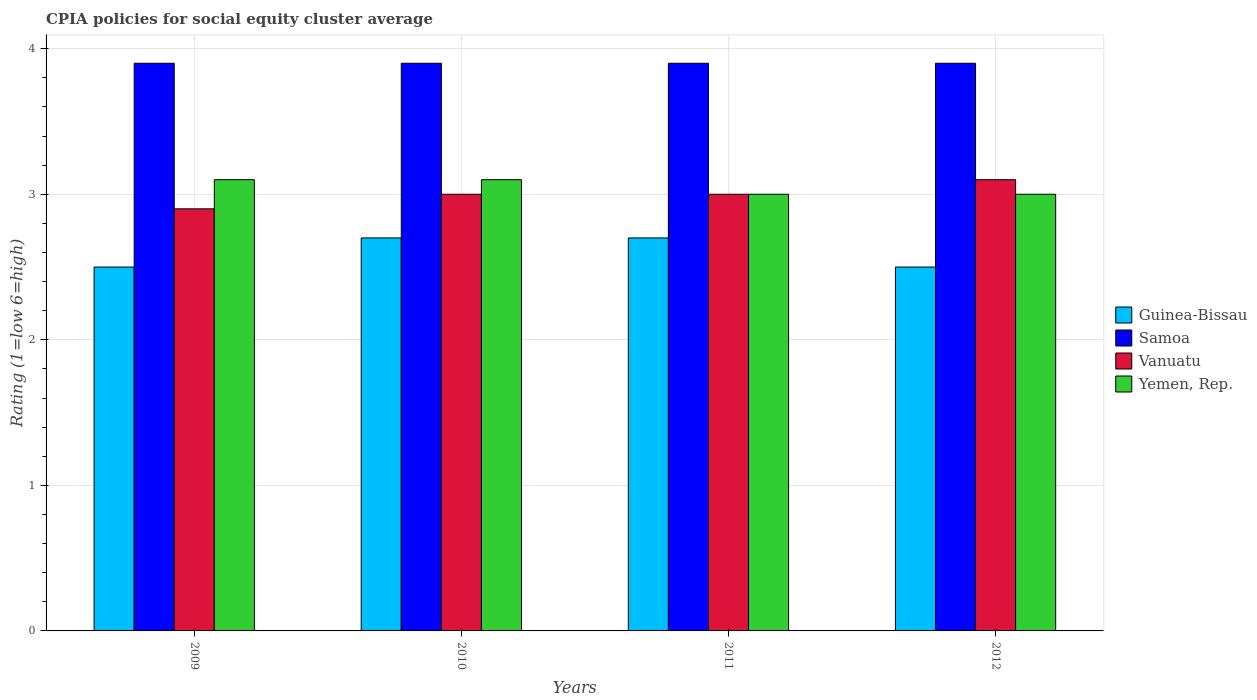How many different coloured bars are there?
Give a very brief answer. 4. Are the number of bars per tick equal to the number of legend labels?
Your answer should be very brief. Yes. What is the difference between the CPIA rating in Guinea-Bissau in 2010 and the CPIA rating in Vanuatu in 2012?
Offer a terse response. -0.4. What is the average CPIA rating in Yemen, Rep. per year?
Offer a very short reply. 3.05. In the year 2009, what is the difference between the CPIA rating in Guinea-Bissau and CPIA rating in Yemen, Rep.?
Your response must be concise. -0.6. In how many years, is the CPIA rating in Samoa greater than 0.8?
Ensure brevity in your answer.  4. Is the CPIA rating in Yemen, Rep. in 2009 less than that in 2012?
Ensure brevity in your answer.  No. What is the difference between the highest and the second highest CPIA rating in Vanuatu?
Provide a short and direct response. 0.1. What is the difference between the highest and the lowest CPIA rating in Yemen, Rep.?
Your answer should be very brief. 0.1. Is the sum of the CPIA rating in Vanuatu in 2009 and 2010 greater than the maximum CPIA rating in Samoa across all years?
Your response must be concise. Yes. Is it the case that in every year, the sum of the CPIA rating in Yemen, Rep. and CPIA rating in Vanuatu is greater than the sum of CPIA rating in Guinea-Bissau and CPIA rating in Samoa?
Offer a very short reply. No. What does the 3rd bar from the left in 2012 represents?
Offer a very short reply. Vanuatu. What does the 4th bar from the right in 2012 represents?
Ensure brevity in your answer.  Guinea-Bissau. How many years are there in the graph?
Offer a very short reply. 4. Does the graph contain grids?
Provide a succinct answer. Yes. How many legend labels are there?
Make the answer very short. 4. How are the legend labels stacked?
Provide a succinct answer. Vertical. What is the title of the graph?
Provide a short and direct response. CPIA policies for social equity cluster average. Does "Sri Lanka" appear as one of the legend labels in the graph?
Offer a terse response. No. What is the Rating (1=low 6=high) of Guinea-Bissau in 2009?
Make the answer very short. 2.5. What is the Rating (1=low 6=high) in Samoa in 2009?
Make the answer very short. 3.9. What is the Rating (1=low 6=high) of Guinea-Bissau in 2010?
Give a very brief answer. 2.7. What is the Rating (1=low 6=high) in Vanuatu in 2010?
Ensure brevity in your answer.  3. What is the Rating (1=low 6=high) in Guinea-Bissau in 2011?
Keep it short and to the point. 2.7. What is the Rating (1=low 6=high) of Samoa in 2011?
Give a very brief answer. 3.9. What is the Rating (1=low 6=high) of Vanuatu in 2011?
Offer a terse response. 3. What is the Rating (1=low 6=high) of Guinea-Bissau in 2012?
Your answer should be compact. 2.5. What is the Rating (1=low 6=high) of Vanuatu in 2012?
Offer a very short reply. 3.1. What is the Rating (1=low 6=high) of Yemen, Rep. in 2012?
Offer a very short reply. 3. Across all years, what is the maximum Rating (1=low 6=high) in Guinea-Bissau?
Provide a short and direct response. 2.7. Across all years, what is the maximum Rating (1=low 6=high) of Samoa?
Ensure brevity in your answer.  3.9. Across all years, what is the maximum Rating (1=low 6=high) of Vanuatu?
Keep it short and to the point. 3.1. Across all years, what is the minimum Rating (1=low 6=high) in Guinea-Bissau?
Ensure brevity in your answer.  2.5. Across all years, what is the minimum Rating (1=low 6=high) of Vanuatu?
Keep it short and to the point. 2.9. What is the total Rating (1=low 6=high) in Samoa in the graph?
Offer a very short reply. 15.6. What is the difference between the Rating (1=low 6=high) of Guinea-Bissau in 2009 and that in 2010?
Ensure brevity in your answer.  -0.2. What is the difference between the Rating (1=low 6=high) in Guinea-Bissau in 2009 and that in 2011?
Give a very brief answer. -0.2. What is the difference between the Rating (1=low 6=high) in Vanuatu in 2009 and that in 2011?
Give a very brief answer. -0.1. What is the difference between the Rating (1=low 6=high) in Guinea-Bissau in 2009 and that in 2012?
Offer a very short reply. 0. What is the difference between the Rating (1=low 6=high) in Samoa in 2009 and that in 2012?
Your response must be concise. 0. What is the difference between the Rating (1=low 6=high) in Vanuatu in 2009 and that in 2012?
Keep it short and to the point. -0.2. What is the difference between the Rating (1=low 6=high) of Yemen, Rep. in 2009 and that in 2012?
Your response must be concise. 0.1. What is the difference between the Rating (1=low 6=high) in Guinea-Bissau in 2010 and that in 2011?
Your response must be concise. 0. What is the difference between the Rating (1=low 6=high) in Vanuatu in 2010 and that in 2011?
Provide a succinct answer. 0. What is the difference between the Rating (1=low 6=high) of Samoa in 2010 and that in 2012?
Your response must be concise. 0. What is the difference between the Rating (1=low 6=high) of Guinea-Bissau in 2009 and the Rating (1=low 6=high) of Vanuatu in 2010?
Your answer should be very brief. -0.5. What is the difference between the Rating (1=low 6=high) in Samoa in 2009 and the Rating (1=low 6=high) in Vanuatu in 2010?
Give a very brief answer. 0.9. What is the difference between the Rating (1=low 6=high) in Guinea-Bissau in 2009 and the Rating (1=low 6=high) in Samoa in 2011?
Your response must be concise. -1.4. What is the difference between the Rating (1=low 6=high) in Guinea-Bissau in 2009 and the Rating (1=low 6=high) in Vanuatu in 2011?
Offer a terse response. -0.5. What is the difference between the Rating (1=low 6=high) in Samoa in 2009 and the Rating (1=low 6=high) in Yemen, Rep. in 2011?
Give a very brief answer. 0.9. What is the difference between the Rating (1=low 6=high) in Vanuatu in 2009 and the Rating (1=low 6=high) in Yemen, Rep. in 2011?
Provide a short and direct response. -0.1. What is the difference between the Rating (1=low 6=high) of Guinea-Bissau in 2009 and the Rating (1=low 6=high) of Yemen, Rep. in 2012?
Your response must be concise. -0.5. What is the difference between the Rating (1=low 6=high) of Samoa in 2009 and the Rating (1=low 6=high) of Vanuatu in 2012?
Keep it short and to the point. 0.8. What is the difference between the Rating (1=low 6=high) in Samoa in 2009 and the Rating (1=low 6=high) in Yemen, Rep. in 2012?
Offer a terse response. 0.9. What is the difference between the Rating (1=low 6=high) of Vanuatu in 2009 and the Rating (1=low 6=high) of Yemen, Rep. in 2012?
Make the answer very short. -0.1. What is the difference between the Rating (1=low 6=high) of Guinea-Bissau in 2010 and the Rating (1=low 6=high) of Yemen, Rep. in 2011?
Ensure brevity in your answer.  -0.3. What is the difference between the Rating (1=low 6=high) of Samoa in 2010 and the Rating (1=low 6=high) of Vanuatu in 2011?
Offer a terse response. 0.9. What is the difference between the Rating (1=low 6=high) in Samoa in 2010 and the Rating (1=low 6=high) in Yemen, Rep. in 2011?
Offer a very short reply. 0.9. What is the difference between the Rating (1=low 6=high) of Vanuatu in 2010 and the Rating (1=low 6=high) of Yemen, Rep. in 2011?
Keep it short and to the point. 0. What is the difference between the Rating (1=low 6=high) in Guinea-Bissau in 2010 and the Rating (1=low 6=high) in Samoa in 2012?
Keep it short and to the point. -1.2. What is the difference between the Rating (1=low 6=high) of Samoa in 2010 and the Rating (1=low 6=high) of Vanuatu in 2012?
Provide a succinct answer. 0.8. What is the difference between the Rating (1=low 6=high) in Vanuatu in 2010 and the Rating (1=low 6=high) in Yemen, Rep. in 2012?
Make the answer very short. 0. What is the average Rating (1=low 6=high) of Samoa per year?
Keep it short and to the point. 3.9. What is the average Rating (1=low 6=high) of Yemen, Rep. per year?
Provide a succinct answer. 3.05. In the year 2009, what is the difference between the Rating (1=low 6=high) of Guinea-Bissau and Rating (1=low 6=high) of Samoa?
Make the answer very short. -1.4. In the year 2009, what is the difference between the Rating (1=low 6=high) in Guinea-Bissau and Rating (1=low 6=high) in Vanuatu?
Give a very brief answer. -0.4. In the year 2009, what is the difference between the Rating (1=low 6=high) of Guinea-Bissau and Rating (1=low 6=high) of Yemen, Rep.?
Keep it short and to the point. -0.6. In the year 2009, what is the difference between the Rating (1=low 6=high) of Vanuatu and Rating (1=low 6=high) of Yemen, Rep.?
Offer a terse response. -0.2. In the year 2010, what is the difference between the Rating (1=low 6=high) in Guinea-Bissau and Rating (1=low 6=high) in Samoa?
Your answer should be compact. -1.2. In the year 2010, what is the difference between the Rating (1=low 6=high) of Guinea-Bissau and Rating (1=low 6=high) of Vanuatu?
Your answer should be very brief. -0.3. In the year 2010, what is the difference between the Rating (1=low 6=high) in Guinea-Bissau and Rating (1=low 6=high) in Yemen, Rep.?
Provide a succinct answer. -0.4. In the year 2010, what is the difference between the Rating (1=low 6=high) in Samoa and Rating (1=low 6=high) in Yemen, Rep.?
Ensure brevity in your answer.  0.8. In the year 2011, what is the difference between the Rating (1=low 6=high) of Guinea-Bissau and Rating (1=low 6=high) of Samoa?
Your response must be concise. -1.2. In the year 2011, what is the difference between the Rating (1=low 6=high) of Guinea-Bissau and Rating (1=low 6=high) of Vanuatu?
Provide a succinct answer. -0.3. In the year 2011, what is the difference between the Rating (1=low 6=high) of Guinea-Bissau and Rating (1=low 6=high) of Yemen, Rep.?
Keep it short and to the point. -0.3. In the year 2011, what is the difference between the Rating (1=low 6=high) in Samoa and Rating (1=low 6=high) in Vanuatu?
Ensure brevity in your answer.  0.9. In the year 2012, what is the difference between the Rating (1=low 6=high) of Guinea-Bissau and Rating (1=low 6=high) of Samoa?
Provide a short and direct response. -1.4. In the year 2012, what is the difference between the Rating (1=low 6=high) in Guinea-Bissau and Rating (1=low 6=high) in Vanuatu?
Provide a short and direct response. -0.6. In the year 2012, what is the difference between the Rating (1=low 6=high) of Samoa and Rating (1=low 6=high) of Vanuatu?
Provide a short and direct response. 0.8. In the year 2012, what is the difference between the Rating (1=low 6=high) of Samoa and Rating (1=low 6=high) of Yemen, Rep.?
Your answer should be very brief. 0.9. What is the ratio of the Rating (1=low 6=high) in Guinea-Bissau in 2009 to that in 2010?
Provide a short and direct response. 0.93. What is the ratio of the Rating (1=low 6=high) of Samoa in 2009 to that in 2010?
Keep it short and to the point. 1. What is the ratio of the Rating (1=low 6=high) of Vanuatu in 2009 to that in 2010?
Provide a succinct answer. 0.97. What is the ratio of the Rating (1=low 6=high) of Guinea-Bissau in 2009 to that in 2011?
Your answer should be compact. 0.93. What is the ratio of the Rating (1=low 6=high) in Samoa in 2009 to that in 2011?
Make the answer very short. 1. What is the ratio of the Rating (1=low 6=high) in Vanuatu in 2009 to that in 2011?
Keep it short and to the point. 0.97. What is the ratio of the Rating (1=low 6=high) of Guinea-Bissau in 2009 to that in 2012?
Ensure brevity in your answer.  1. What is the ratio of the Rating (1=low 6=high) in Vanuatu in 2009 to that in 2012?
Your answer should be compact. 0.94. What is the ratio of the Rating (1=low 6=high) of Yemen, Rep. in 2009 to that in 2012?
Provide a short and direct response. 1.03. What is the ratio of the Rating (1=low 6=high) in Samoa in 2010 to that in 2011?
Offer a very short reply. 1. What is the ratio of the Rating (1=low 6=high) of Guinea-Bissau in 2010 to that in 2012?
Your answer should be very brief. 1.08. What is the ratio of the Rating (1=low 6=high) of Samoa in 2010 to that in 2012?
Provide a short and direct response. 1. What is the ratio of the Rating (1=low 6=high) in Vanuatu in 2010 to that in 2012?
Give a very brief answer. 0.97. What is the ratio of the Rating (1=low 6=high) in Yemen, Rep. in 2010 to that in 2012?
Give a very brief answer. 1.03. What is the ratio of the Rating (1=low 6=high) in Vanuatu in 2011 to that in 2012?
Your response must be concise. 0.97. What is the difference between the highest and the second highest Rating (1=low 6=high) of Samoa?
Make the answer very short. 0. What is the difference between the highest and the second highest Rating (1=low 6=high) in Vanuatu?
Give a very brief answer. 0.1. What is the difference between the highest and the lowest Rating (1=low 6=high) of Guinea-Bissau?
Your answer should be very brief. 0.2. What is the difference between the highest and the lowest Rating (1=low 6=high) of Yemen, Rep.?
Your answer should be compact. 0.1. 